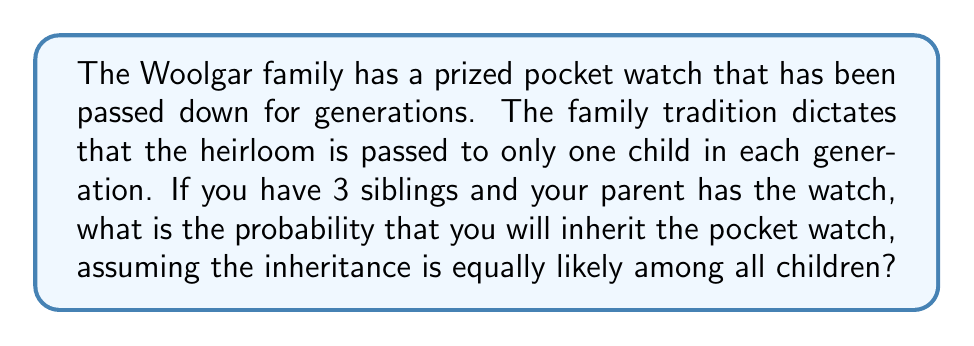Help me with this question. To solve this problem, we need to consider the following:

1. The total number of children (including you) who could potentially inherit the watch.
2. The probability of each child inheriting the watch.

Let's break it down step-by-step:

1. Total number of children:
   You have 3 siblings, and including yourself, there are 4 children in total.

2. Probability calculation:
   Since the inheritance is equally likely among all children, each child has an equal chance of receiving the watch.

   The probability of you inheriting the watch is:

   $$P(\text{inheriting the watch}) = \frac{\text{favorable outcomes}}{\text{total possible outcomes}} = \frac{1}{4}$$

   This is because there is only one favorable outcome (you inheriting the watch) out of four possible outcomes (any of the four children inheriting the watch).

3. Expressing the probability as a percentage:
   To convert the fraction to a percentage, we multiply by 100:

   $$\frac{1}{4} \times 100 = 25\%$$

Therefore, the probability of you inheriting the Woolgar family's prized pocket watch is $\frac{1}{4}$ or 25%.
Answer: $\frac{1}{4}$ or 25% 